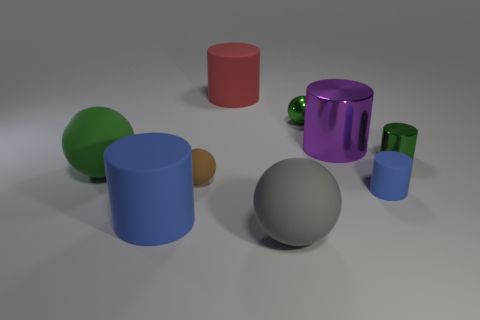Subtract 2 cylinders. How many cylinders are left? 3 Subtract all cyan cylinders. Subtract all red spheres. How many cylinders are left? 5 Subtract all cylinders. How many objects are left? 4 Add 5 red metal things. How many red metal things exist? 5 Subtract 0 red blocks. How many objects are left? 9 Subtract all small rubber balls. Subtract all big blue objects. How many objects are left? 7 Add 3 large gray things. How many large gray things are left? 4 